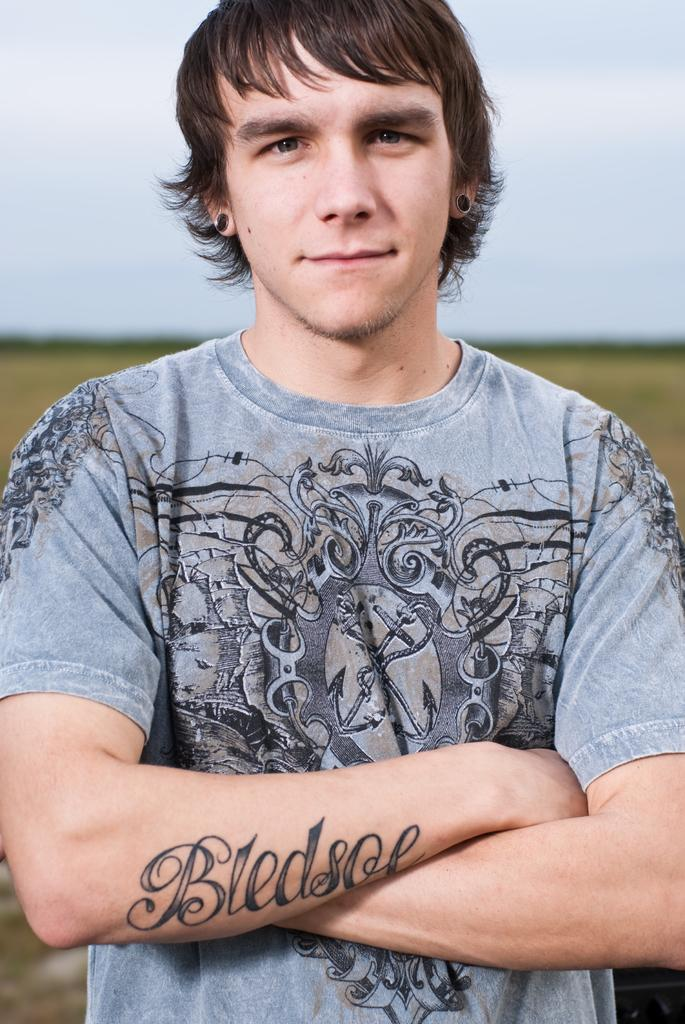Who is in the image? There is a man in the image. What is the man doing in the image? The man is watching and folding his hands. What is the man wearing in the image? The man is wearing a t-shirt. Can you describe any unique features of the man? There is a tattoo on the man's hand. How would you describe the background of the image? The background of the image has a blurred view. What color can be seen in the image? The color white is present in the image. What type of sail can be seen on the man's shirt in the image? There is no sail present on the man's shirt in the image; he is wearing a t-shirt. Is the man in the image a prisoner? There is no indication in the image that the man is a prisoner. 